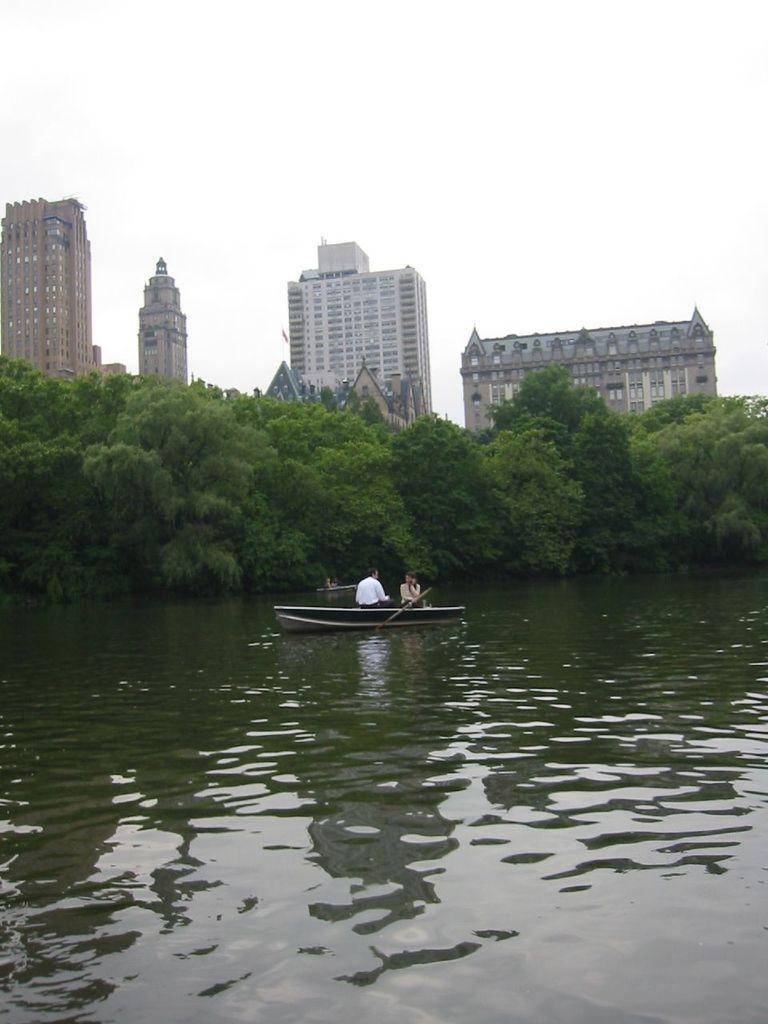Please provide a concise description of this image. In the picture we can see a water which is green in color and in it we can see a boat with two persons sitting on it and in the background we can see trees, buildings, tower buildings and sky. 